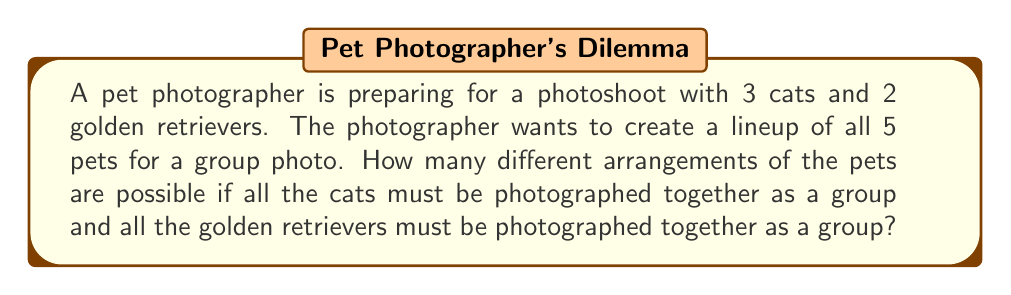Help me with this question. Let's approach this step-by-step:

1) First, we can consider the cats as one unit and the golden retrievers as another unit. This means we essentially have 2 units to arrange.

2) The number of ways to arrange 2 units is simply $2! = 2 \times 1 = 2$.

3) However, within each unit, the pets can also be arranged in different ways:
   - For the cats: There are 3! ways to arrange 3 cats.
   - For the golden retrievers: There are 2! ways to arrange 2 golden retrievers.

4) By the Multiplication Principle, the total number of arrangements is:

   $$ \text{Total arrangements} = 2! \times 3! \times 2! $$

5) Let's calculate this:
   $$ 2! \times 3! \times 2! = 2 \times 6 \times 2 = 24 $$

Therefore, there are 24 possible different arrangements of the pets for the group photo.
Answer: 24 